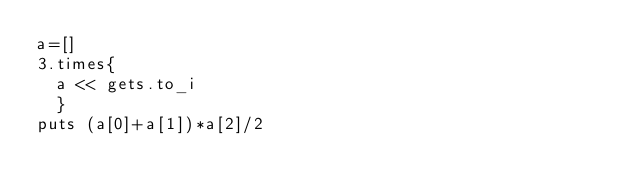<code> <loc_0><loc_0><loc_500><loc_500><_Ruby_>a=[]
3.times{
  a << gets.to_i
  }
puts (a[0]+a[1])*a[2]/2</code> 